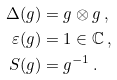<formula> <loc_0><loc_0><loc_500><loc_500>\Delta ( g ) & = g \otimes g \, , \\ \varepsilon ( g ) & = 1 \in { \mathbb { C } } \, , \\ S ( g ) & = g ^ { - 1 } \, .</formula> 